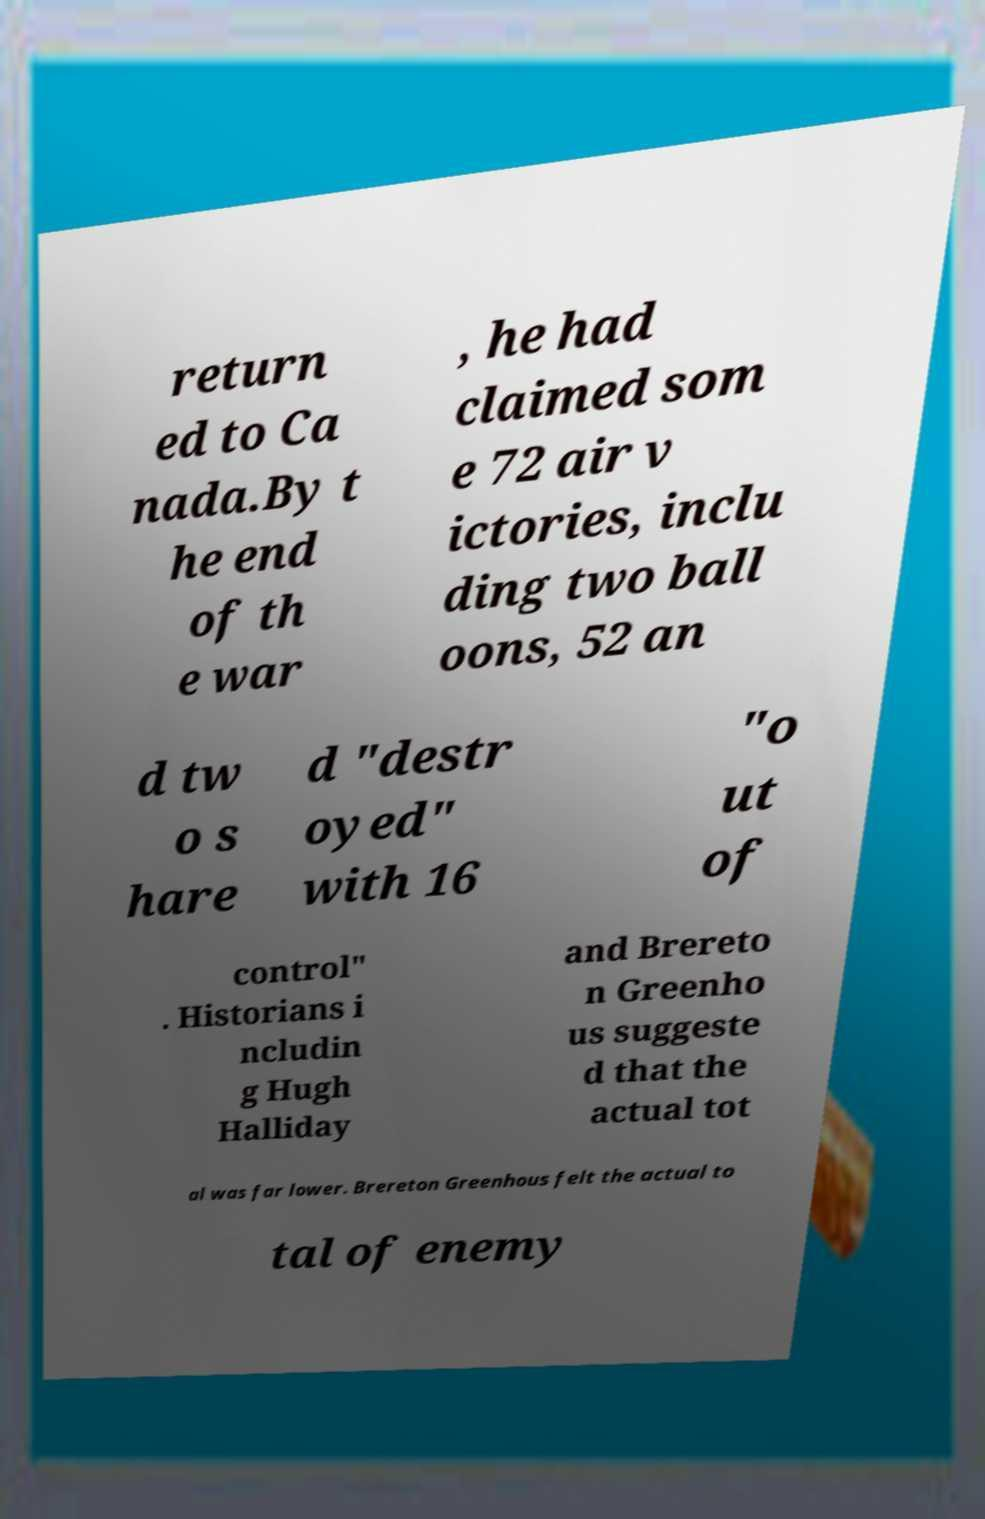Can you accurately transcribe the text from the provided image for me? return ed to Ca nada.By t he end of th e war , he had claimed som e 72 air v ictories, inclu ding two ball oons, 52 an d tw o s hare d "destr oyed" with 16 "o ut of control" . Historians i ncludin g Hugh Halliday and Brereto n Greenho us suggeste d that the actual tot al was far lower. Brereton Greenhous felt the actual to tal of enemy 